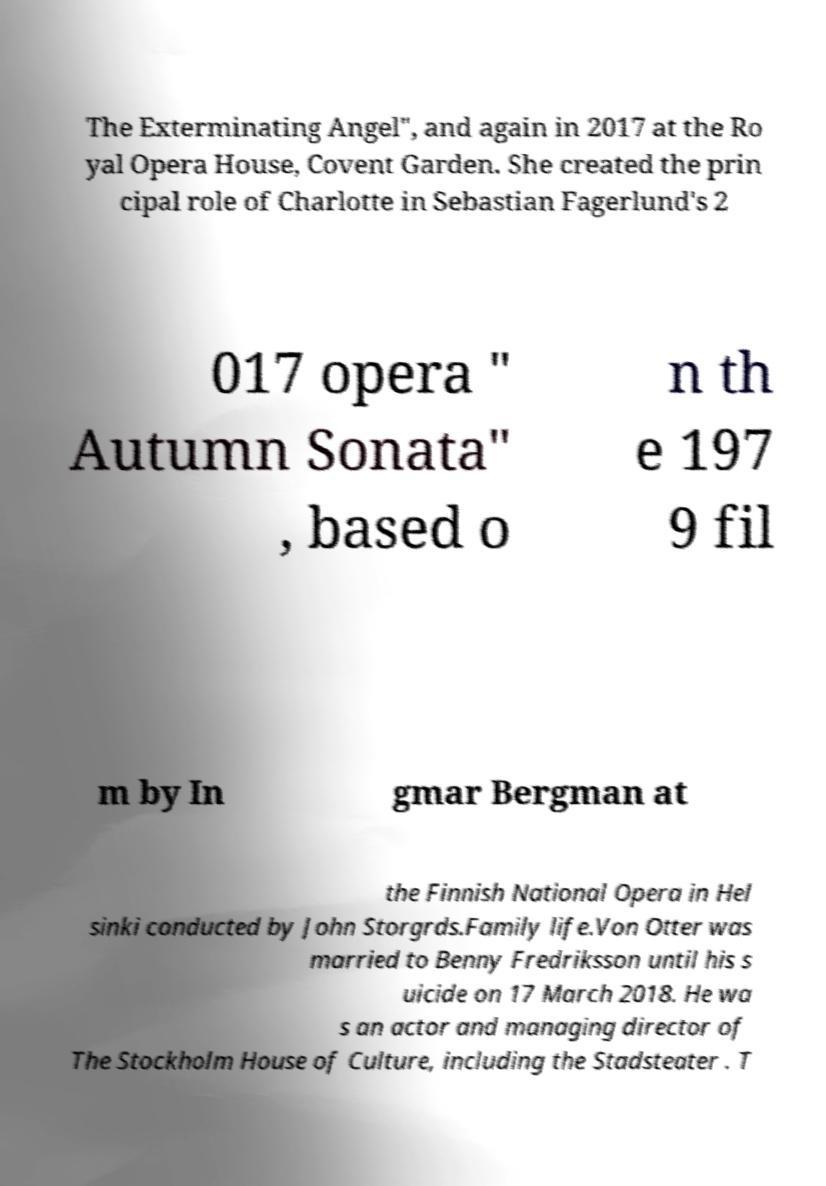There's text embedded in this image that I need extracted. Can you transcribe it verbatim? The Exterminating Angel", and again in 2017 at the Ro yal Opera House, Covent Garden. She created the prin cipal role of Charlotte in Sebastian Fagerlund's 2 017 opera " Autumn Sonata" , based o n th e 197 9 fil m by In gmar Bergman at the Finnish National Opera in Hel sinki conducted by John Storgrds.Family life.Von Otter was married to Benny Fredriksson until his s uicide on 17 March 2018. He wa s an actor and managing director of The Stockholm House of Culture, including the Stadsteater . T 